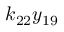Convert formula to latex. <formula><loc_0><loc_0><loc_500><loc_500>k _ { 2 2 } y _ { 1 9 }</formula> 